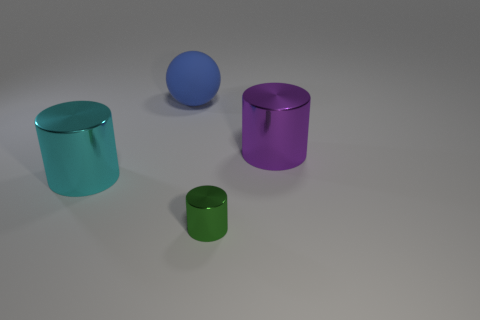There is a big object that is in front of the large shiny object that is on the right side of the tiny cylinder; how many cylinders are behind it?
Ensure brevity in your answer.  1. How many balls are rubber objects or cyan rubber objects?
Keep it short and to the point. 1. What color is the metallic cylinder in front of the large shiny cylinder that is on the left side of the cylinder right of the tiny metallic object?
Give a very brief answer. Green. How many other things are there of the same size as the cyan object?
Make the answer very short. 2. Are there any other things that have the same shape as the rubber object?
Your answer should be very brief. No. The other tiny object that is the same shape as the cyan metallic thing is what color?
Provide a short and direct response. Green. What is the color of the tiny cylinder that is made of the same material as the purple thing?
Your answer should be very brief. Green. Are there the same number of things that are on the left side of the tiny green metallic cylinder and things?
Your answer should be compact. No. There is a object behind the purple cylinder; is its size the same as the large cyan shiny cylinder?
Your response must be concise. Yes. What is the color of the other metallic object that is the same size as the cyan shiny thing?
Offer a very short reply. Purple. 